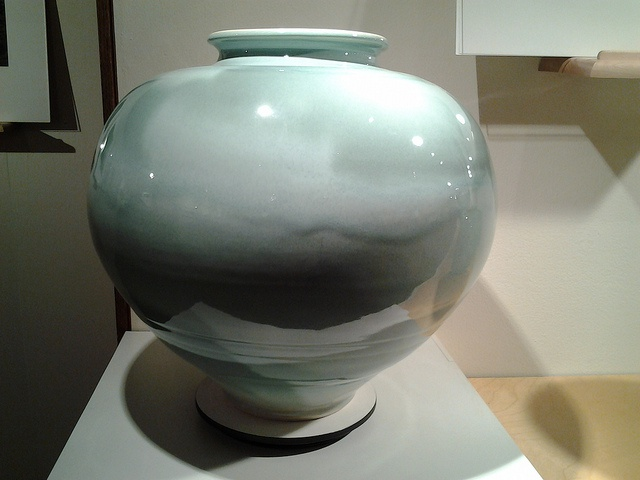Describe the objects in this image and their specific colors. I can see a vase in black, gray, darkgray, and ivory tones in this image. 